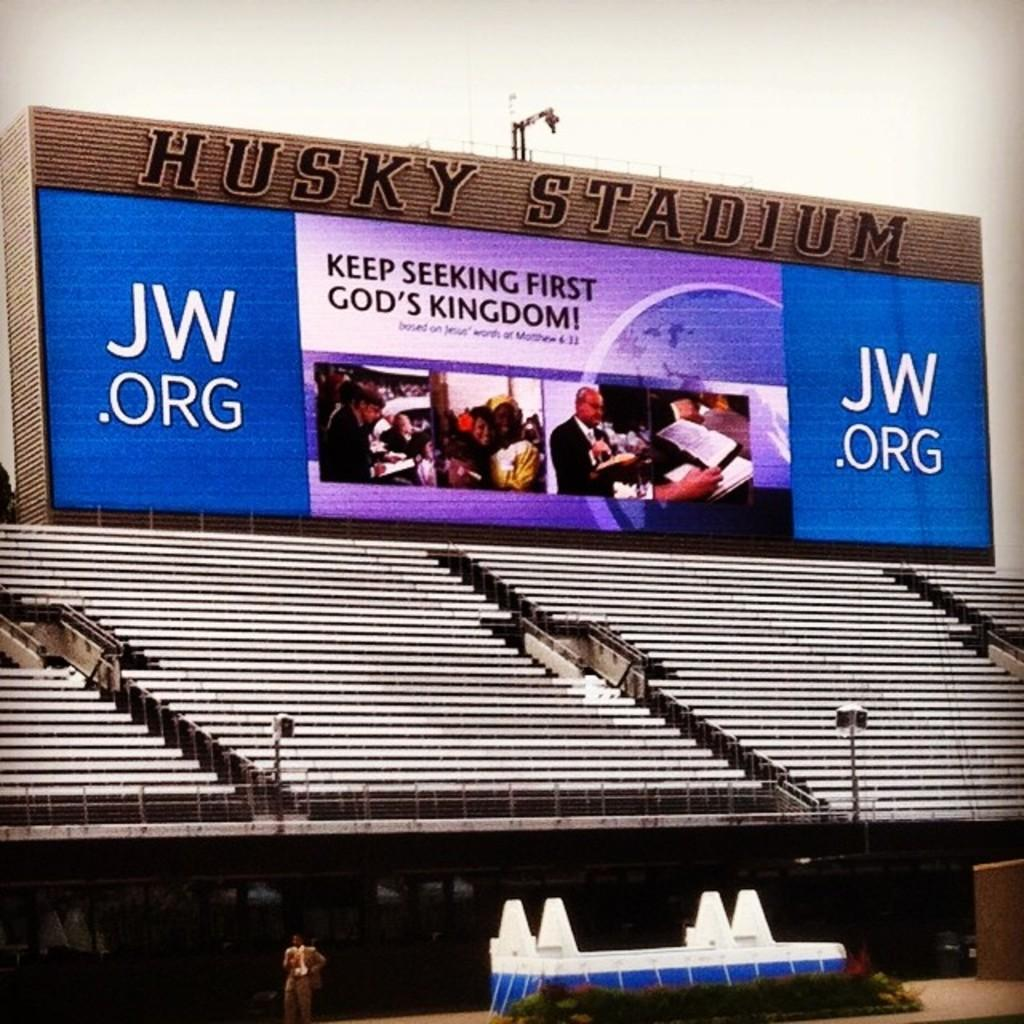<image>
Relay a brief, clear account of the picture shown. An advert for jw.org, a religious speaker, looms overan empty stand in a stadium. 